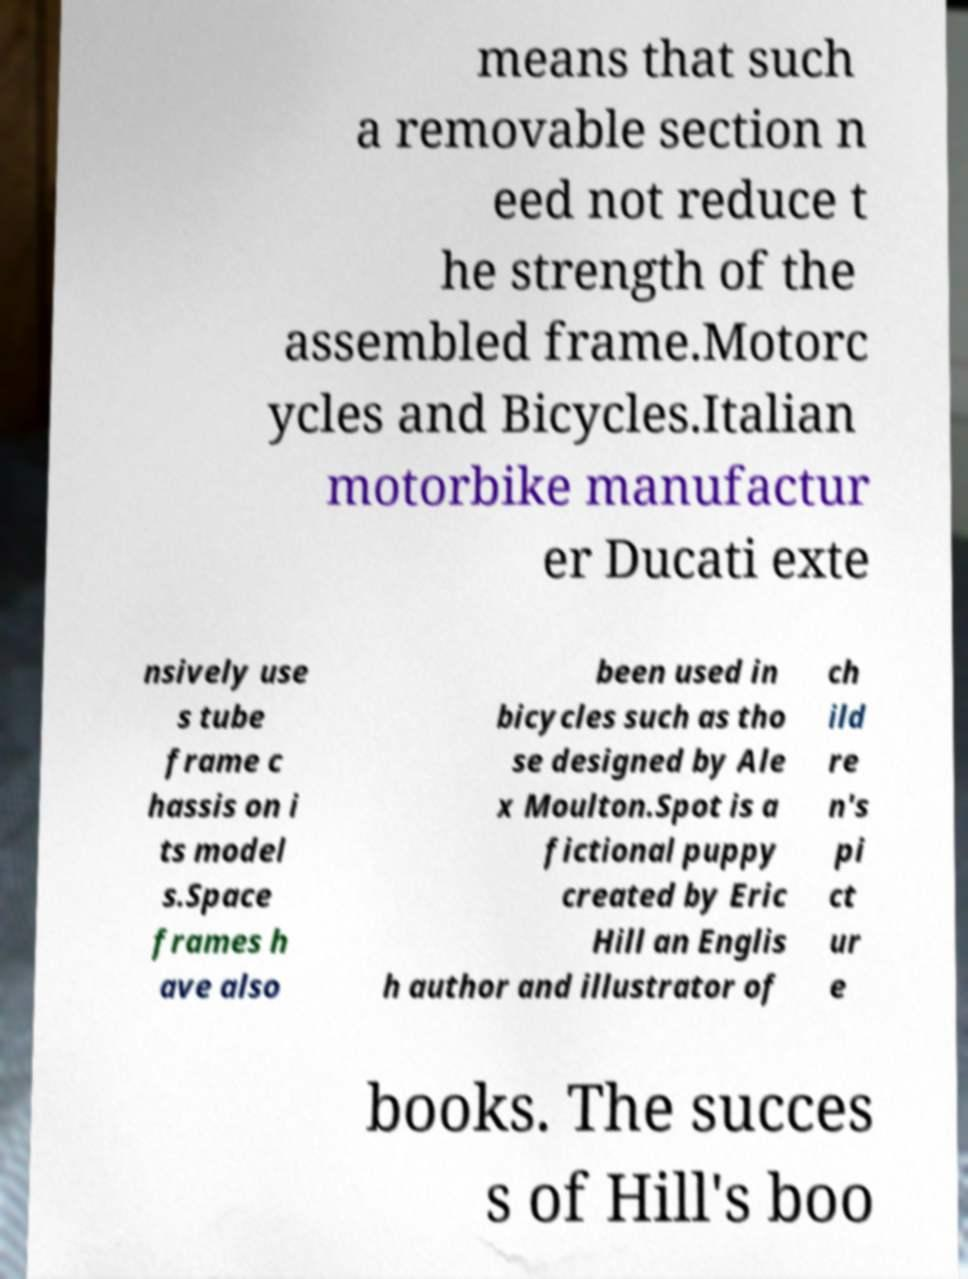Please read and relay the text visible in this image. What does it say? means that such a removable section n eed not reduce t he strength of the assembled frame.Motorc ycles and Bicycles.Italian motorbike manufactur er Ducati exte nsively use s tube frame c hassis on i ts model s.Space frames h ave also been used in bicycles such as tho se designed by Ale x Moulton.Spot is a fictional puppy created by Eric Hill an Englis h author and illustrator of ch ild re n's pi ct ur e books. The succes s of Hill's boo 